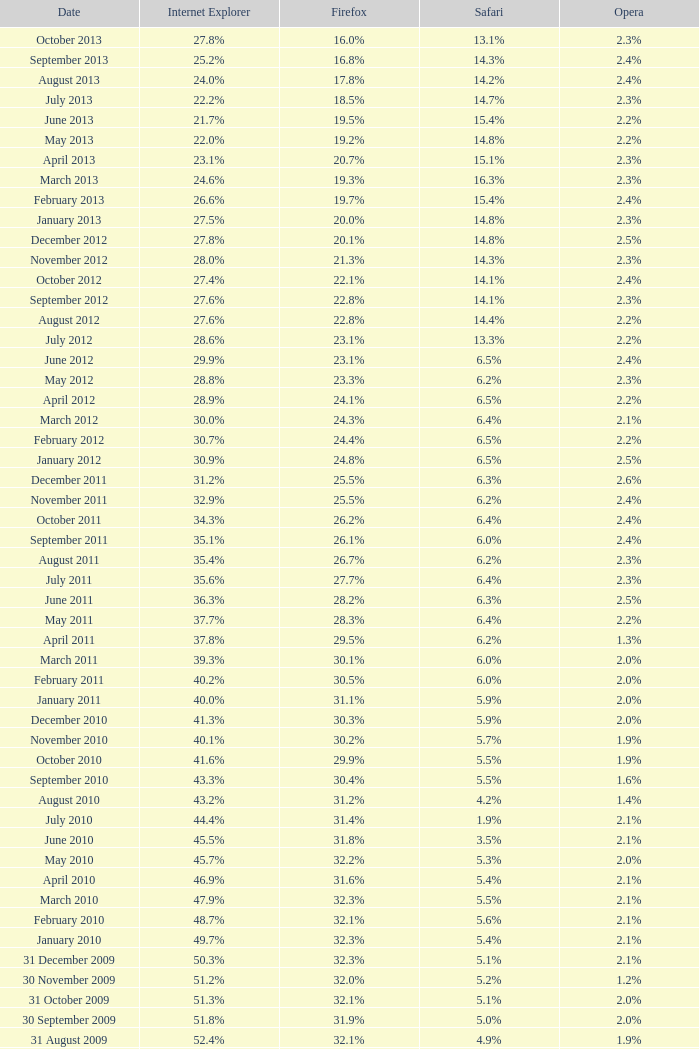When did internet explorer reach a 6 31 January 2008. 